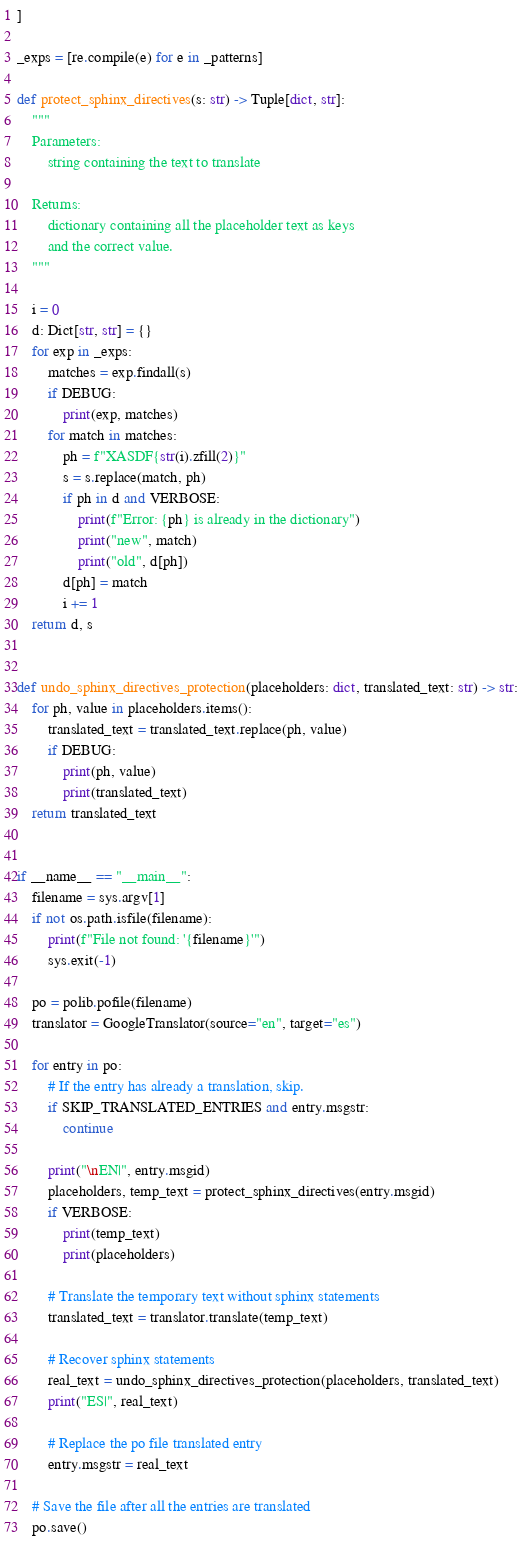<code> <loc_0><loc_0><loc_500><loc_500><_Python_>]

_exps = [re.compile(e) for e in _patterns]

def protect_sphinx_directives(s: str) -> Tuple[dict, str]:
    """
    Parameters:
        string containing the text to translate

    Returns:
        dictionary containing all the placeholder text as keys
        and the correct value.
    """

    i = 0
    d: Dict[str, str] = {}
    for exp in _exps:
        matches = exp.findall(s)
        if DEBUG:
            print(exp, matches)
        for match in matches:
            ph = f"XASDF{str(i).zfill(2)}"
            s = s.replace(match, ph)
            if ph in d and VERBOSE:
                print(f"Error: {ph} is already in the dictionary")
                print("new", match)
                print("old", d[ph])
            d[ph] = match
            i += 1
    return d, s


def undo_sphinx_directives_protection(placeholders: dict, translated_text: str) -> str:
    for ph, value in placeholders.items():
        translated_text = translated_text.replace(ph, value)
        if DEBUG:
            print(ph, value)
            print(translated_text)
    return translated_text


if __name__ == "__main__":
    filename = sys.argv[1]
    if not os.path.isfile(filename):
        print(f"File not found: '{filename}'")
        sys.exit(-1)

    po = polib.pofile(filename)
    translator = GoogleTranslator(source="en", target="es")

    for entry in po:
        # If the entry has already a translation, skip.
        if SKIP_TRANSLATED_ENTRIES and entry.msgstr:
            continue

        print("\nEN|", entry.msgid)
        placeholders, temp_text = protect_sphinx_directives(entry.msgid)
        if VERBOSE:
            print(temp_text)
            print(placeholders)

        # Translate the temporary text without sphinx statements
        translated_text = translator.translate(temp_text)

        # Recover sphinx statements
        real_text = undo_sphinx_directives_protection(placeholders, translated_text)
        print("ES|", real_text)

        # Replace the po file translated entry
        entry.msgstr = real_text

    # Save the file after all the entries are translated
    po.save()
</code> 